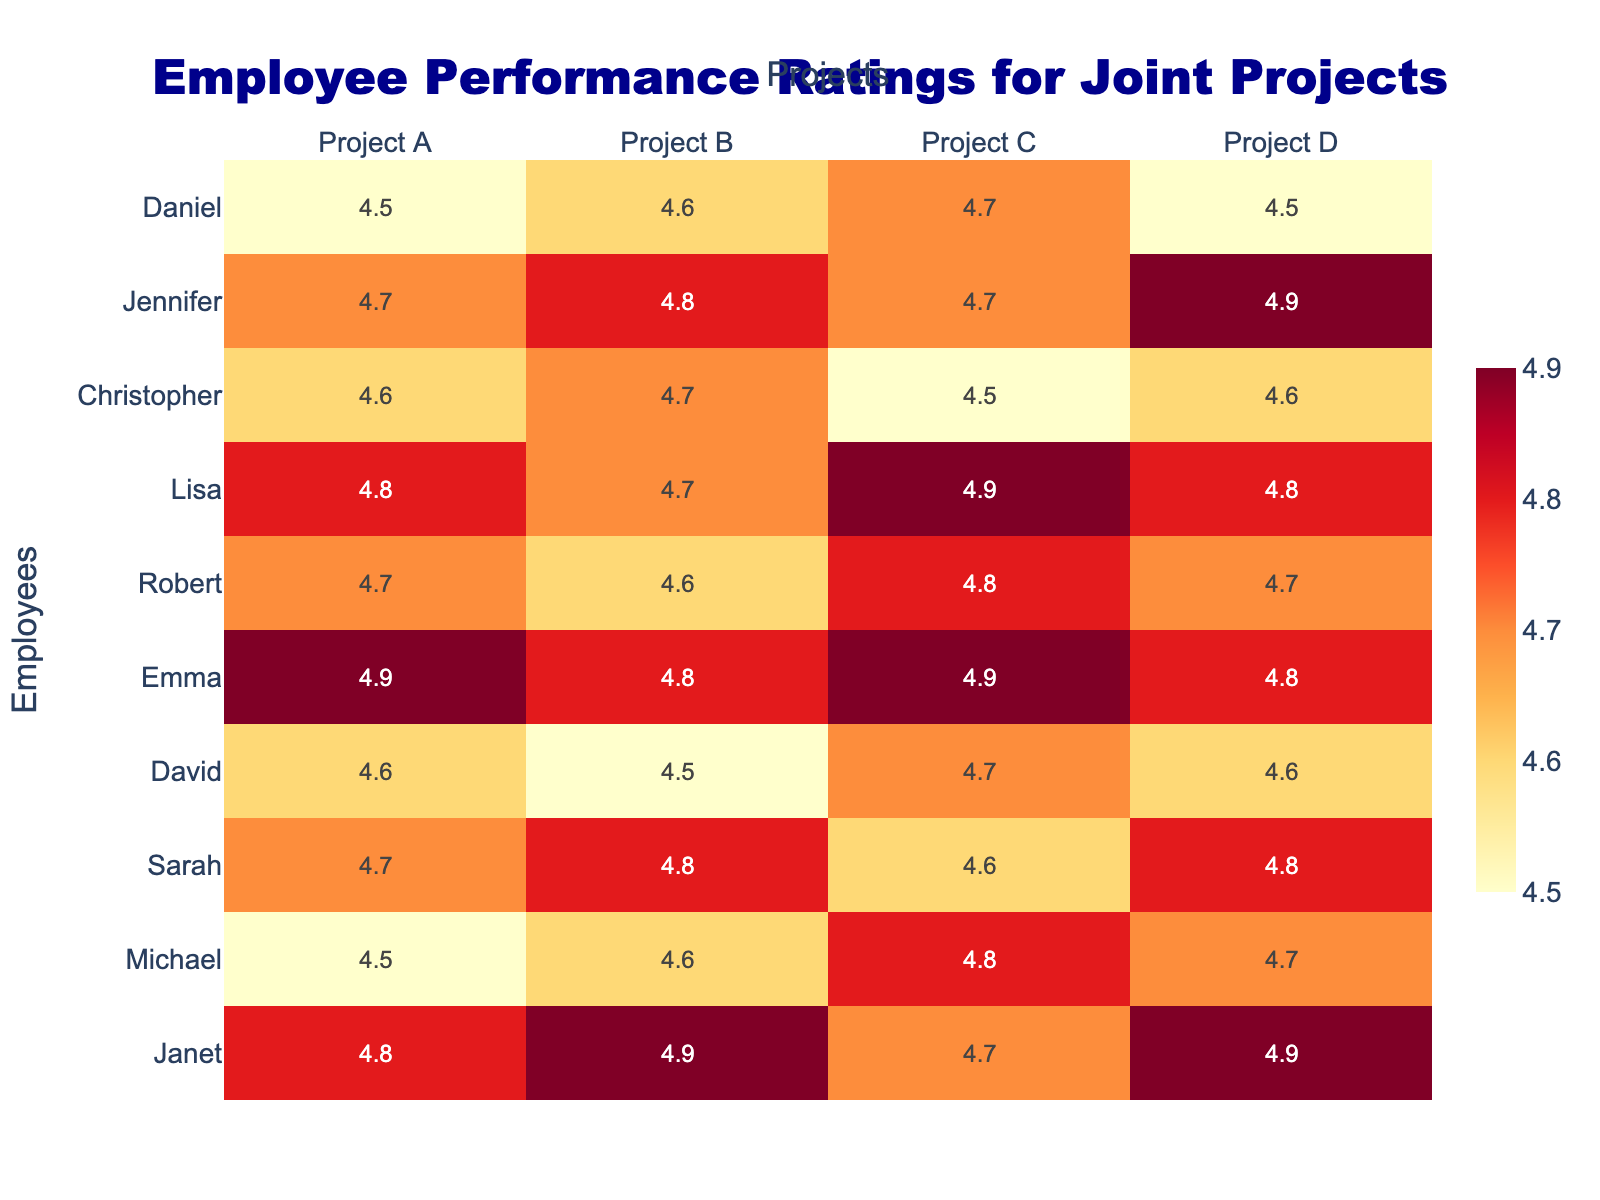What is Janet's rating for Project C? The table lists Janet's ratings for each project. For Project C, her rating is directly visible as 4.7.
Answer: 4.7 Which employee has the highest rating in Project D? Looking at the table for Project D, I can see that both Janet and Emma have the highest rating of 4.9.
Answer: Janet and Emma What is the average rating for Project A? To find the average, I add the ratings for Project A: (4.8 + 4.5 + 4.7 + 4.6 + 4.9 + 4.7 + 4.8 + 4.6 + 4.7 + 4.5) = 46.2. There are 10 ratings, so the average is 46.2 / 10 = 4.62.
Answer: 4.62 Did any employee rate all projects 4.8 or higher? Upon reviewing each employee's ratings, I find that both Emma and Lisa have all ratings at or above 4.8.
Answer: Yes What is the difference between the highest and the lowest rating in Project B? In Project B, the highest rating is 4.9 (by Janet and Emma), and the lowest is 4.5 (by David and Daniel). The difference is 4.9 - 4.5 = 0.4.
Answer: 0.4 Which employee received the lowest rating for Project C? In Project C, Sarah has the lowest rating of 4.6, compared to others.
Answer: Sarah Which project has the highest average rating across all employees? Calculating the average for each project: Project A: 4.62, Project B: 4.66, Project C: 4.69, Project D: 4.66. The highest average rating is for Project C at 4.69.
Answer: Project C Is there a project where all ratings are equal or the same? By examining all the ratings for each project, I notice that none of the projects have the same rating from all employees; they all vary.
Answer: No 